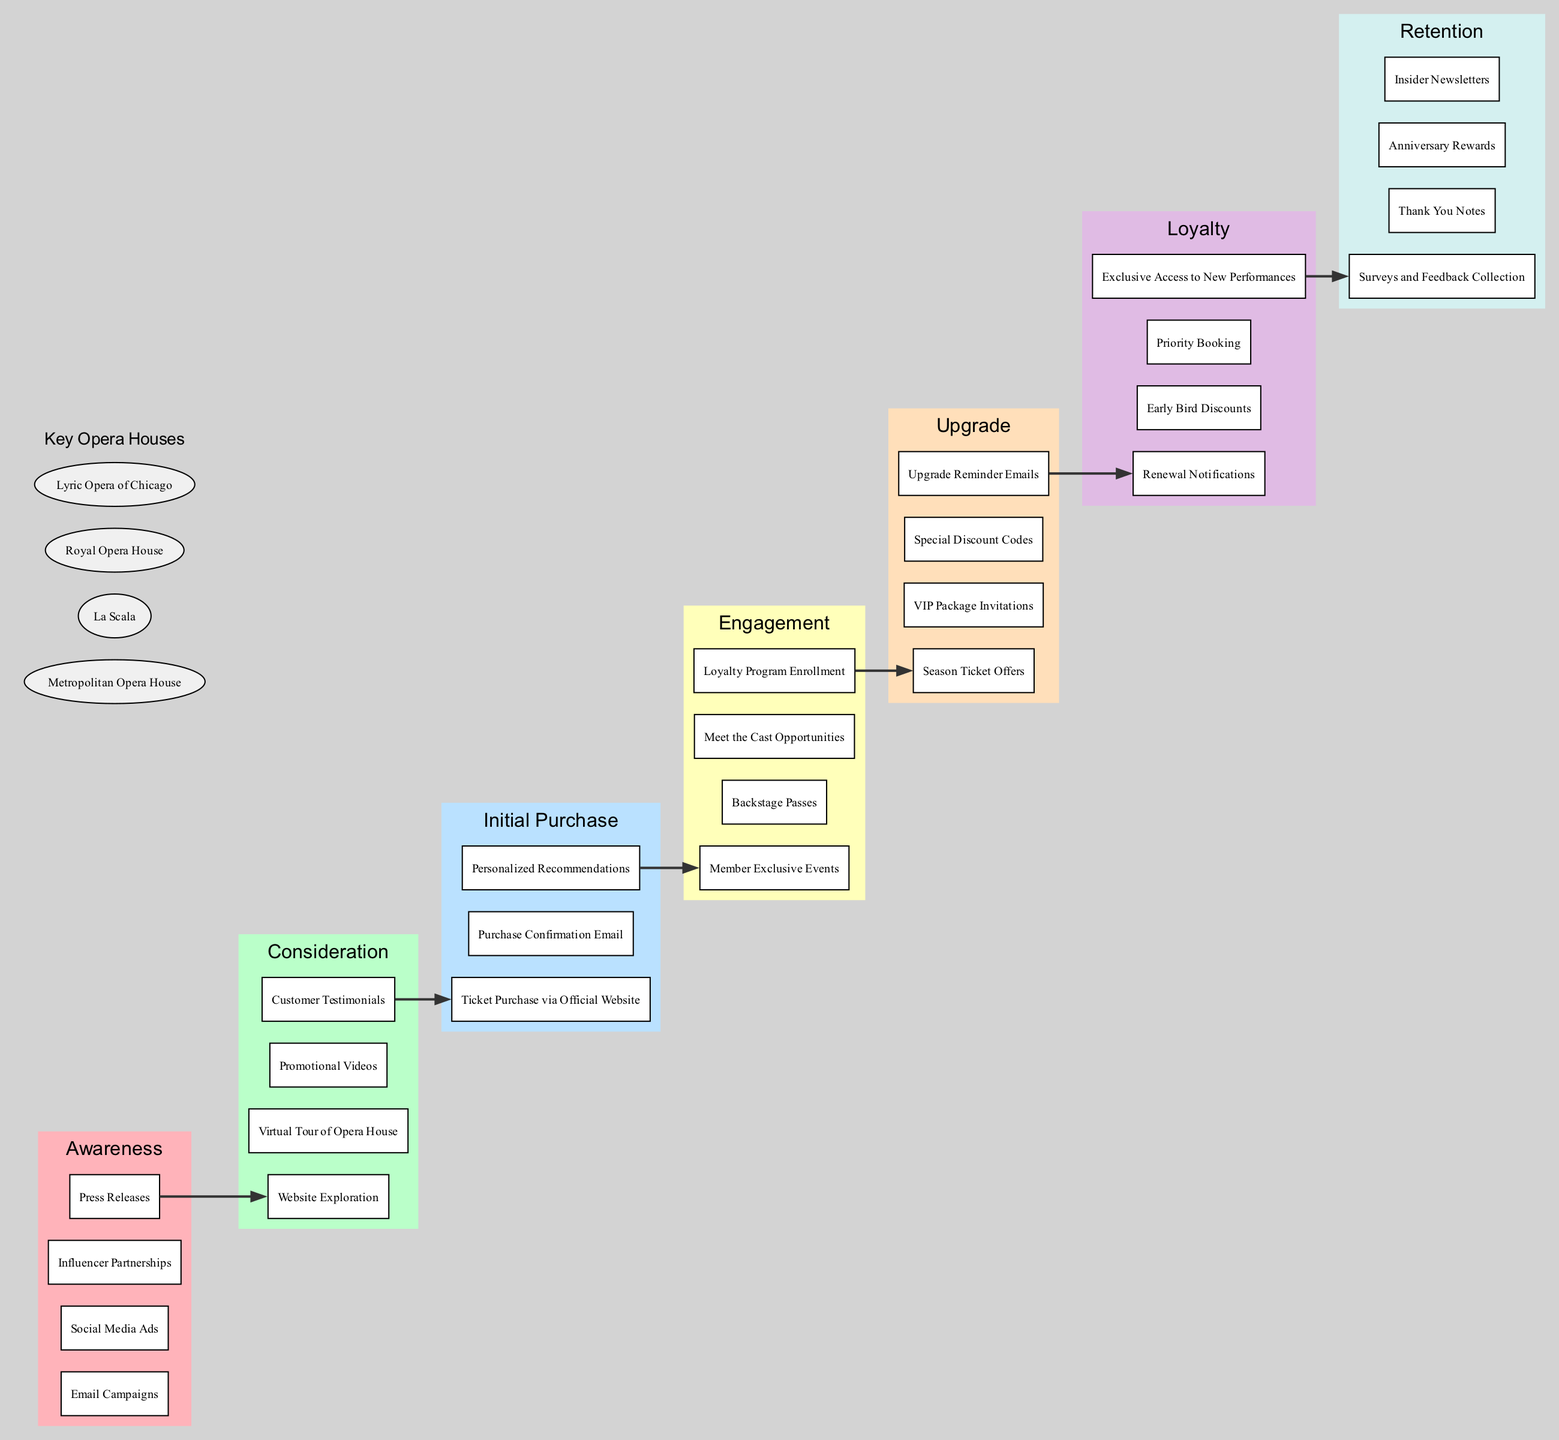What is the first stage in the pathway? The first stage is labeled “Awareness” in the diagram, indicating it is the starting point of the patron ticket purchasing pathway.
Answer: Awareness How many elements are in the "Engagement" stage? The "Engagement" stage contains four elements: Member Exclusive Events, Backstage Passes, Meet the Cast Opportunities, and Loyalty Program Enrollment.
Answer: 4 What does the final stage of the pathway represent? The final stage is labeled “Retention,” which signifies the last phase in the patron journey focused on maintaining patron relationships.
Answer: Retention Which stage follows "Initial Purchase"? "Engagement" follows "Initial Purchase," indicating the next step after a patron buys their ticket.
Answer: Engagement What key house is listed after "Loyalty"? The next entity listed under key houses after the "Loyalty" stage is "Metropolitan Opera House," showing it as a notable organization related to the pathway.
Answer: Metropolitan Opera House What is the link between "Consideration" and "Initial Purchase"? The link is represented by an edge connecting an element of "Consideration" to the first element of "Initial Purchase," indicating the flow from considering a ticket to making a purchase.
Answer: Ticket Purchase via Official Website How many stages are presented in this pathway? The diagram has a total of seven distinct stages, starting from "Awareness" and ending at "Retention."
Answer: 7 What type of events does the "Engagement" stage include? The "Engagement" stage includes exclusive opportunities, such as Member Exclusive Events, designed to deepen involvement with patrons.
Answer: Member Exclusive Events Which stage contains “Special Discount Codes”? “Special Discount Codes” is part of the "Upgrade" stage, highlighting options for patrons to enhance their ticket purchases.
Answer: Upgrade 